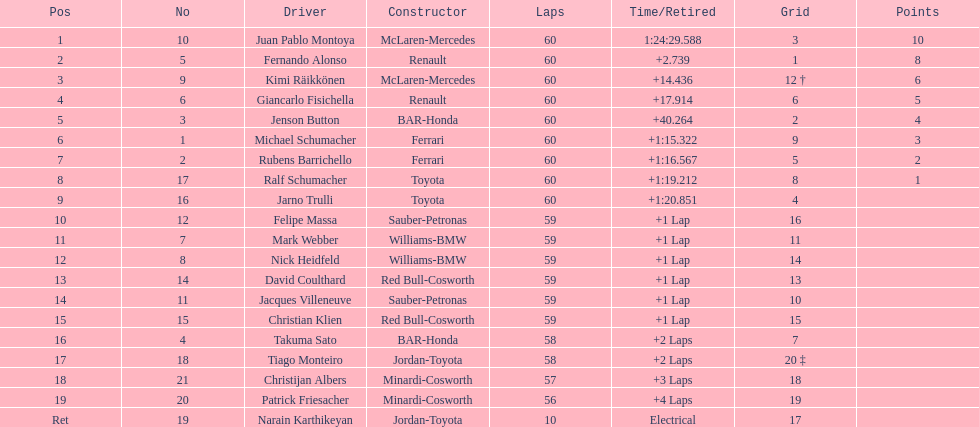Following the 8th place, how many points are awarded to a driver? 0. 